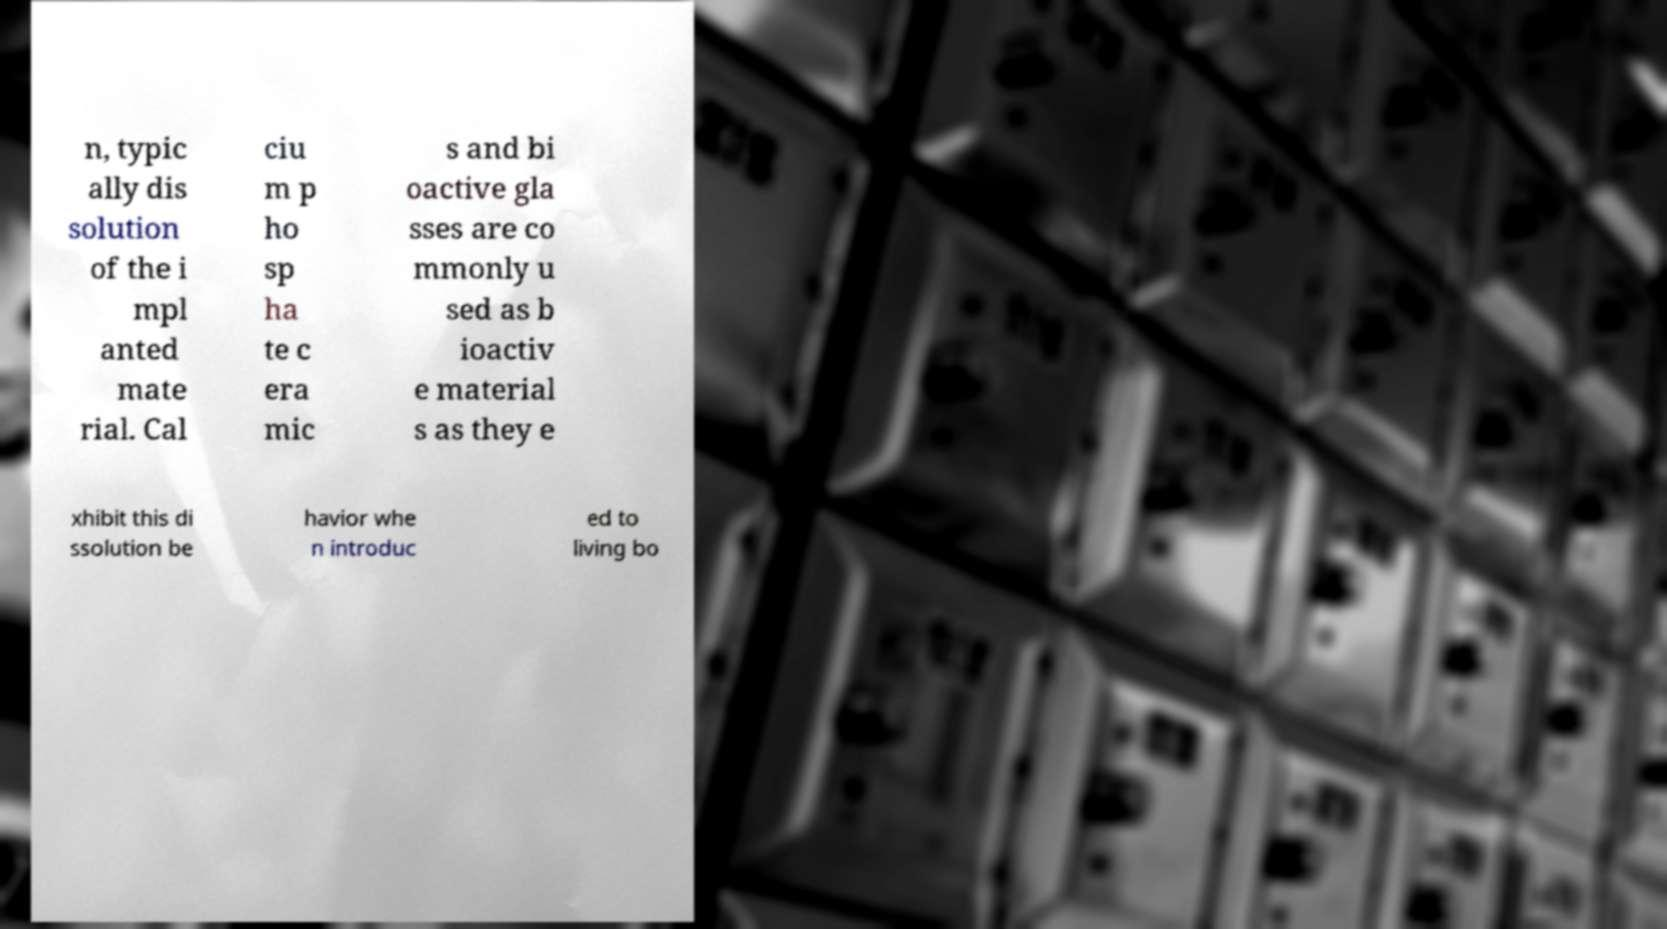Please identify and transcribe the text found in this image. n, typic ally dis solution of the i mpl anted mate rial. Cal ciu m p ho sp ha te c era mic s and bi oactive gla sses are co mmonly u sed as b ioactiv e material s as they e xhibit this di ssolution be havior whe n introduc ed to living bo 